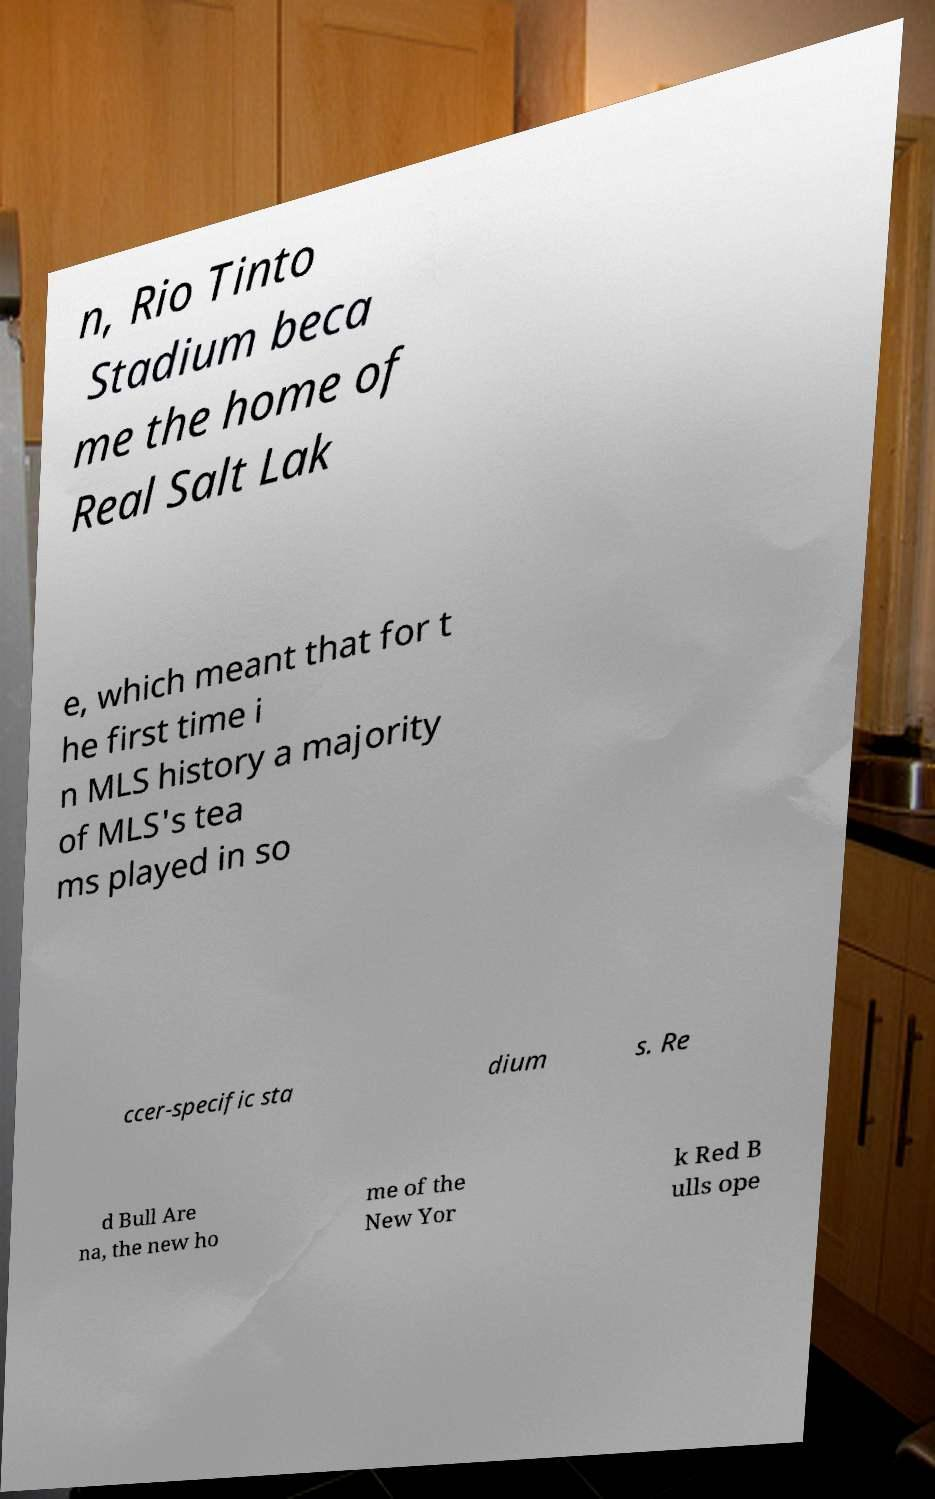Could you assist in decoding the text presented in this image and type it out clearly? n, Rio Tinto Stadium beca me the home of Real Salt Lak e, which meant that for t he first time i n MLS history a majority of MLS's tea ms played in so ccer-specific sta dium s. Re d Bull Are na, the new ho me of the New Yor k Red B ulls ope 